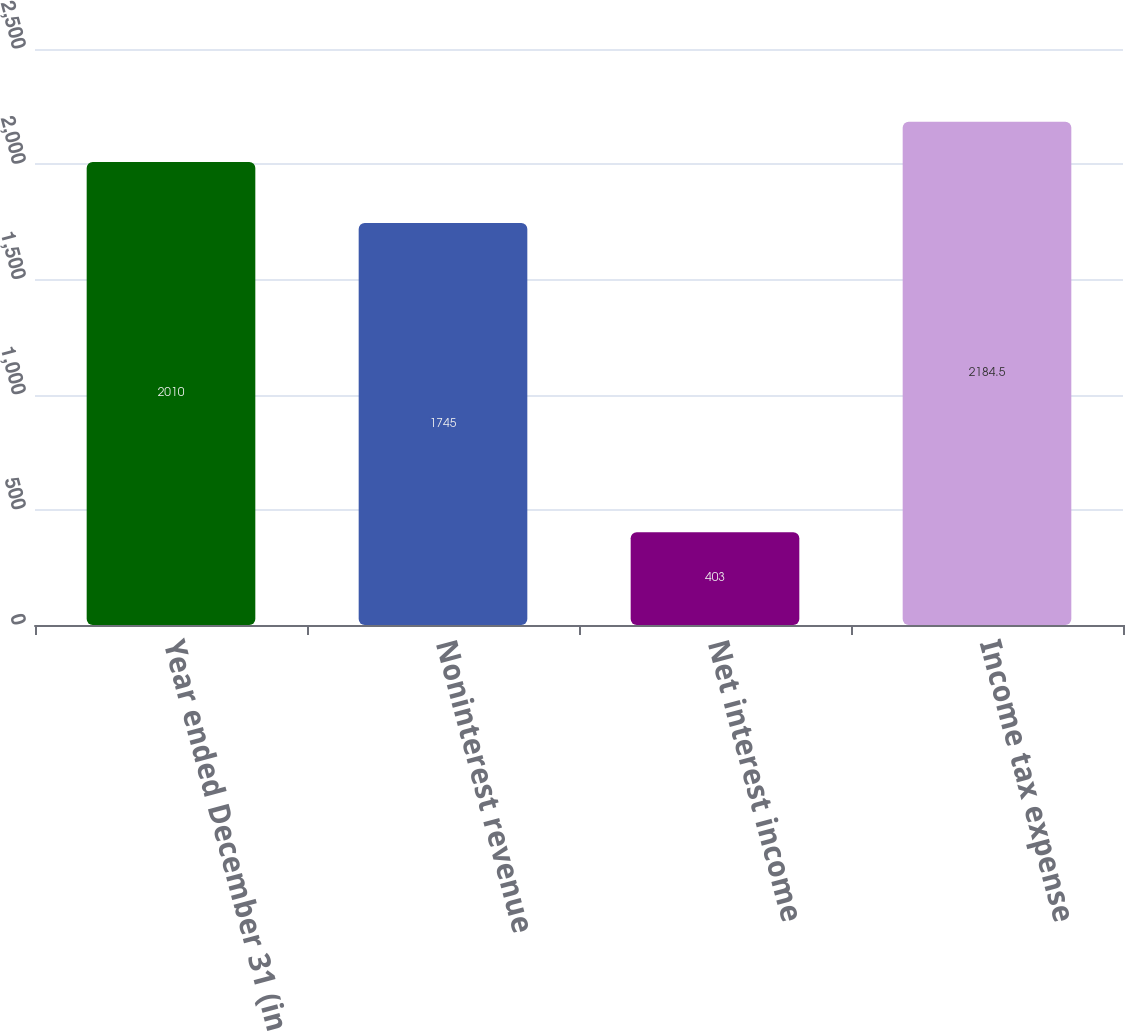Convert chart to OTSL. <chart><loc_0><loc_0><loc_500><loc_500><bar_chart><fcel>Year ended December 31 (in<fcel>Noninterest revenue<fcel>Net interest income<fcel>Income tax expense<nl><fcel>2010<fcel>1745<fcel>403<fcel>2184.5<nl></chart> 